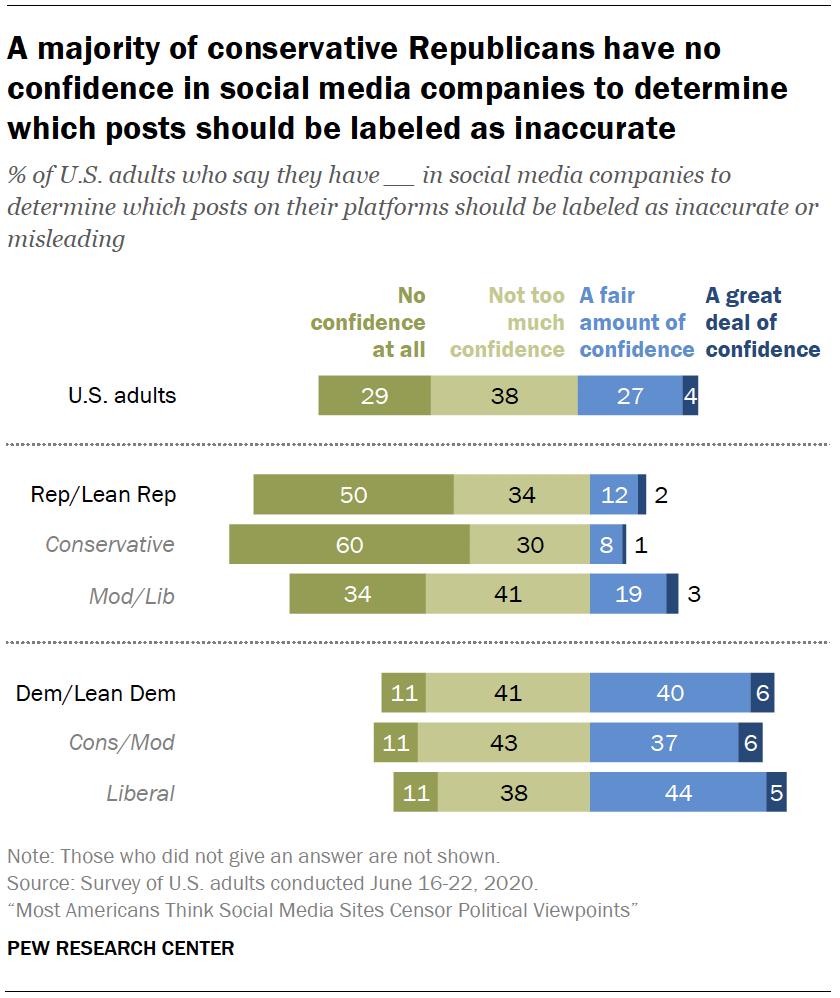Point out several critical features in this image. The largest value of the light blue bar is 44. Is the median of light blue bars and dark green bar equal? The answer is no. 